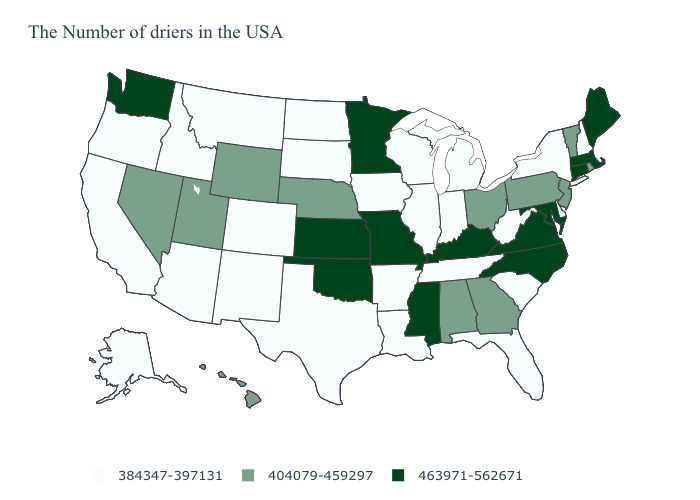How many symbols are there in the legend?
Answer briefly. 3. Does California have the lowest value in the USA?
Be succinct. Yes. What is the value of Minnesota?
Be succinct. 463971-562671. Does the first symbol in the legend represent the smallest category?
Quick response, please. Yes. Is the legend a continuous bar?
Answer briefly. No. Does North Dakota have a lower value than Alaska?
Keep it brief. No. What is the value of Mississippi?
Write a very short answer. 463971-562671. Which states have the lowest value in the MidWest?
Quick response, please. Michigan, Indiana, Wisconsin, Illinois, Iowa, South Dakota, North Dakota. Among the states that border New York , does Pennsylvania have the lowest value?
Quick response, please. Yes. Name the states that have a value in the range 463971-562671?
Concise answer only. Maine, Massachusetts, Connecticut, Maryland, Virginia, North Carolina, Kentucky, Mississippi, Missouri, Minnesota, Kansas, Oklahoma, Washington. Name the states that have a value in the range 384347-397131?
Quick response, please. New Hampshire, New York, Delaware, South Carolina, West Virginia, Florida, Michigan, Indiana, Tennessee, Wisconsin, Illinois, Louisiana, Arkansas, Iowa, Texas, South Dakota, North Dakota, Colorado, New Mexico, Montana, Arizona, Idaho, California, Oregon, Alaska. What is the highest value in the USA?
Answer briefly. 463971-562671. What is the value of Maryland?
Give a very brief answer. 463971-562671. Name the states that have a value in the range 404079-459297?
Short answer required. Rhode Island, Vermont, New Jersey, Pennsylvania, Ohio, Georgia, Alabama, Nebraska, Wyoming, Utah, Nevada, Hawaii. 